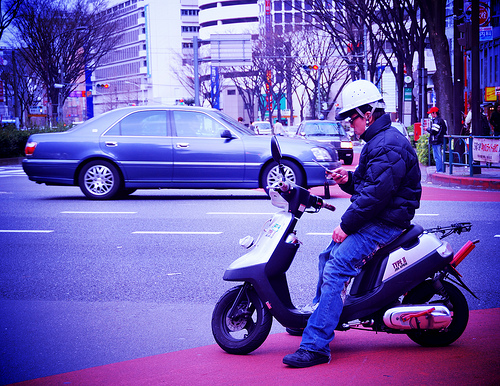How many scooters are there? There is one scooter visible in the image, with a rider wearing a white helmet preparing to ride it. 